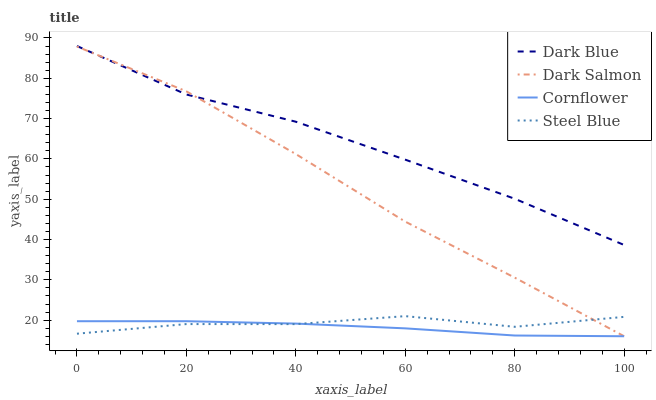Does Cornflower have the minimum area under the curve?
Answer yes or no. Yes. Does Dark Blue have the maximum area under the curve?
Answer yes or no. Yes. Does Steel Blue have the minimum area under the curve?
Answer yes or no. No. Does Steel Blue have the maximum area under the curve?
Answer yes or no. No. Is Cornflower the smoothest?
Answer yes or no. Yes. Is Steel Blue the roughest?
Answer yes or no. Yes. Is Dark Salmon the smoothest?
Answer yes or no. No. Is Dark Salmon the roughest?
Answer yes or no. No. Does Steel Blue have the lowest value?
Answer yes or no. No. Does Dark Blue have the highest value?
Answer yes or no. Yes. Does Steel Blue have the highest value?
Answer yes or no. No. Is Steel Blue less than Dark Blue?
Answer yes or no. Yes. Is Dark Blue greater than Steel Blue?
Answer yes or no. Yes. Does Dark Blue intersect Dark Salmon?
Answer yes or no. Yes. Is Dark Blue less than Dark Salmon?
Answer yes or no. No. Is Dark Blue greater than Dark Salmon?
Answer yes or no. No. Does Steel Blue intersect Dark Blue?
Answer yes or no. No. 